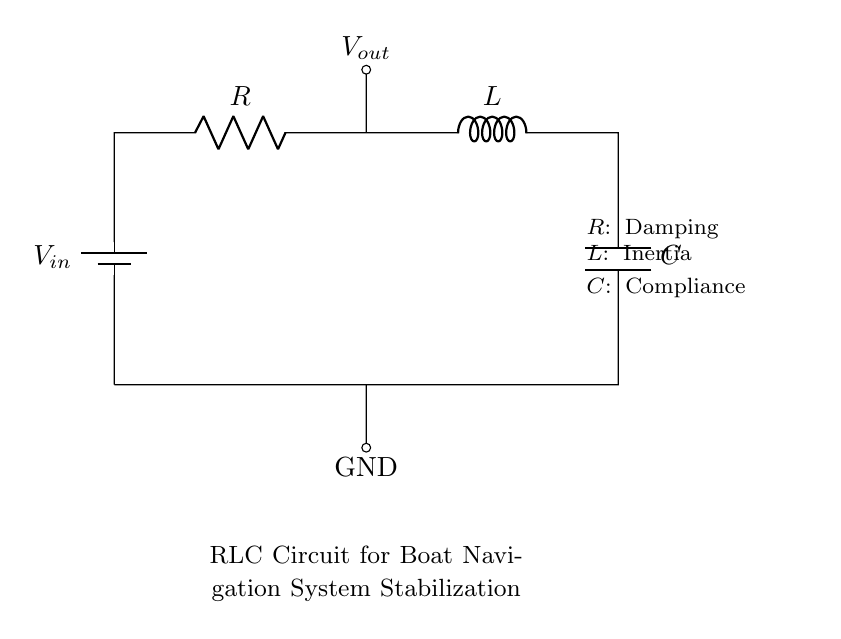What are the components of the circuit? The circuit contains a resistor, inductor, capacitor, and a voltage source, as labeled in the diagram.
Answer: resistor, inductor, capacitor, voltage source What is the role of the resistor in this circuit? The resistor is used for damping, which helps to reduce oscillations and stabilize the circuit.
Answer: damping What does the inductor represent in the context of this circuit? The inductor represents inertia, which relates to how the circuit responds to changing currents and can affect stabilization.
Answer: inertia What is the output voltage node labeled as? The output voltage node is labeled as Vout, indicating where the output voltage can be measured in the circuit.
Answer: Vout How does the capacitor function within the circuit? The capacitor is responsible for compliance, which allows the circuit to respond to changes in voltage and current conditions effectively.
Answer: compliance In what way does this RLC circuit contribute to boat navigation system stabilization? The RLC circuit filters the responses to changing conditions, dampens oscillations, and provides a stable output for navigation control.
Answer: stabilization What kind of feedback does this RLC configuration provide? This configuration typically provides a second-order feedback system, which is effective for controlling oscillatory behavior in the circuit.
Answer: second-order feedback 